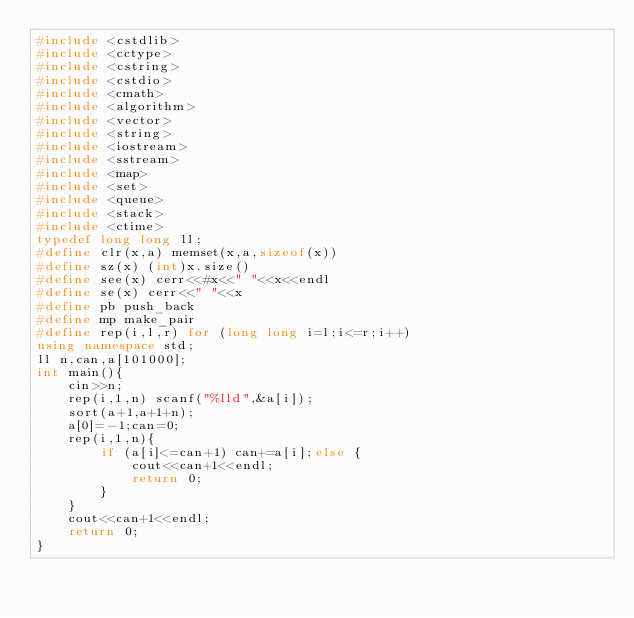Convert code to text. <code><loc_0><loc_0><loc_500><loc_500><_C++_>#include <cstdlib>
#include <cctype>
#include <cstring>
#include <cstdio>
#include <cmath>
#include <algorithm>
#include <vector>
#include <string>
#include <iostream>
#include <sstream>
#include <map>
#include <set>
#include <queue>
#include <stack>
#include <ctime>
typedef long long ll;
#define clr(x,a) memset(x,a,sizeof(x))
#define sz(x) (int)x.size()
#define see(x) cerr<<#x<<" "<<x<<endl
#define se(x) cerr<<" "<<x
#define pb push_back
#define mp make_pair
#define rep(i,l,r) for (long long i=l;i<=r;i++)
using namespace std;
ll n,can,a[101000];
int main(){
    cin>>n;
    rep(i,1,n) scanf("%lld",&a[i]);
    sort(a+1,a+1+n);
    a[0]=-1;can=0;
    rep(i,1,n){
        if (a[i]<=can+1) can+=a[i];else {
            cout<<can+1<<endl;
            return 0;
        }
    }
    cout<<can+1<<endl;
    return 0;
}</code> 